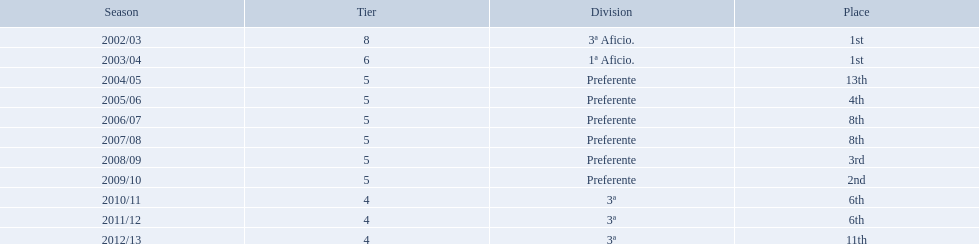What place did the team place in 2010/11? 6th. In what other year did they place 6th? 2011/12. What ranking did the team obtain in 2010/11? 6th. In what additional year did they finish 6th? 2011/12. How many occasions did internacional de madrid cf finish in 6th position? 6th, 6th. What is the initial season that the squad finished in 6th place? 2010/11. In which season following the initial did they rank 6th once more? 2011/12. What spot did the team secure in 2010/11? 6th. In what alternate year did they hold 6th place? 2011/12. During which seasons did the tier four competitions occur? 2010/11, 2011/12, 2012/13. Among these seasons, which had a team finishing in 6th place? 2010/11, 2011/12. Which of the leftover seasons was the latest? 2011/12. Which seasons involved playing in the fourth tier? 2010/11, 2011/12, 2012/13. In these seasons, which one had a team ending in 6th position? 2010/11, 2011/12. Out of the remaining seasons, which one took place last? 2011/12. In the 2010/11 season, what position did the team achieve? 6th. In which other year did they rank 6th? 2011/12. What was the team's ranking in the 2010/11 season? 6th. In what additional year did they secure a 6th place finish? 2011/12. During the 2010/11 season, where did the team place? 6th. In what other year did they manage to place 6th? 2011/12. In how many instances has internacional de madrid cf finished in 6th position? 6th, 6th. During which season did they achieve 6th place for the first time? 2010/11. In which subsequent season did they secure 6th position once more? 2011/12. How often has internacional de madrid cf ranked 6th? 6th, 6th. In which season did the team first reach this position? 2010/11. Following the first time, in which season did they place 6th again? 2011/12. Could you help me parse every detail presented in this table? {'header': ['Season', 'Tier', 'Division', 'Place'], 'rows': [['2002/03', '8', '3ª Aficio.', '1st'], ['2003/04', '6', '1ª Aficio.', '1st'], ['2004/05', '5', 'Preferente', '13th'], ['2005/06', '5', 'Preferente', '4th'], ['2006/07', '5', 'Preferente', '8th'], ['2007/08', '5', 'Preferente', '8th'], ['2008/09', '5', 'Preferente', '3rd'], ['2009/10', '5', 'Preferente', '2nd'], ['2010/11', '4', '3ª', '6th'], ['2011/12', '4', '3ª', '6th'], ['2012/13', '4', '3ª', '11th']]} On how many occasions has internacional de madrid cf attained a 6th place finish? 6th, 6th. When was the first season they achieved this ranking? 2010/11. In which season after the initial one did they again achieve a 6th place standing? 2011/12. 